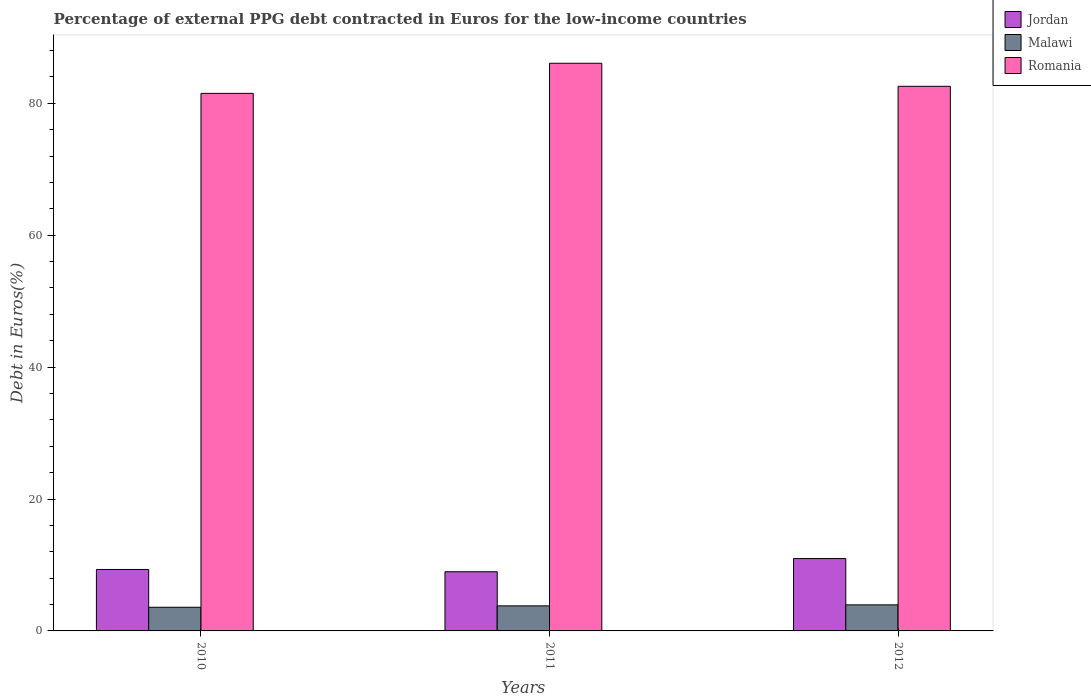Are the number of bars on each tick of the X-axis equal?
Your answer should be very brief. Yes. What is the label of the 2nd group of bars from the left?
Offer a very short reply. 2011. In how many cases, is the number of bars for a given year not equal to the number of legend labels?
Your answer should be compact. 0. What is the percentage of external PPG debt contracted in Euros in Jordan in 2012?
Keep it short and to the point. 10.97. Across all years, what is the maximum percentage of external PPG debt contracted in Euros in Jordan?
Provide a succinct answer. 10.97. Across all years, what is the minimum percentage of external PPG debt contracted in Euros in Romania?
Give a very brief answer. 81.51. In which year was the percentage of external PPG debt contracted in Euros in Malawi maximum?
Keep it short and to the point. 2012. What is the total percentage of external PPG debt contracted in Euros in Malawi in the graph?
Provide a succinct answer. 11.34. What is the difference between the percentage of external PPG debt contracted in Euros in Jordan in 2010 and that in 2011?
Provide a succinct answer. 0.34. What is the difference between the percentage of external PPG debt contracted in Euros in Jordan in 2011 and the percentage of external PPG debt contracted in Euros in Romania in 2010?
Offer a terse response. -72.53. What is the average percentage of external PPG debt contracted in Euros in Malawi per year?
Your answer should be very brief. 3.78. In the year 2012, what is the difference between the percentage of external PPG debt contracted in Euros in Jordan and percentage of external PPG debt contracted in Euros in Malawi?
Provide a succinct answer. 7.02. What is the ratio of the percentage of external PPG debt contracted in Euros in Malawi in 2011 to that in 2012?
Your answer should be very brief. 0.96. What is the difference between the highest and the second highest percentage of external PPG debt contracted in Euros in Romania?
Your answer should be compact. 3.49. What is the difference between the highest and the lowest percentage of external PPG debt contracted in Euros in Romania?
Your answer should be compact. 4.57. What does the 3rd bar from the left in 2012 represents?
Provide a succinct answer. Romania. What does the 3rd bar from the right in 2010 represents?
Offer a terse response. Jordan. Are all the bars in the graph horizontal?
Keep it short and to the point. No. How many years are there in the graph?
Your answer should be very brief. 3. Does the graph contain any zero values?
Ensure brevity in your answer.  No. Does the graph contain grids?
Your response must be concise. No. What is the title of the graph?
Your answer should be very brief. Percentage of external PPG debt contracted in Euros for the low-income countries. What is the label or title of the X-axis?
Make the answer very short. Years. What is the label or title of the Y-axis?
Your response must be concise. Debt in Euros(%). What is the Debt in Euros(%) of Jordan in 2010?
Your answer should be very brief. 9.32. What is the Debt in Euros(%) in Malawi in 2010?
Your answer should be compact. 3.59. What is the Debt in Euros(%) of Romania in 2010?
Offer a very short reply. 81.51. What is the Debt in Euros(%) in Jordan in 2011?
Offer a very short reply. 8.97. What is the Debt in Euros(%) of Malawi in 2011?
Give a very brief answer. 3.8. What is the Debt in Euros(%) in Romania in 2011?
Your answer should be very brief. 86.07. What is the Debt in Euros(%) in Jordan in 2012?
Your answer should be very brief. 10.97. What is the Debt in Euros(%) in Malawi in 2012?
Provide a short and direct response. 3.95. What is the Debt in Euros(%) in Romania in 2012?
Your answer should be compact. 82.58. Across all years, what is the maximum Debt in Euros(%) of Jordan?
Your response must be concise. 10.97. Across all years, what is the maximum Debt in Euros(%) in Malawi?
Provide a succinct answer. 3.95. Across all years, what is the maximum Debt in Euros(%) of Romania?
Keep it short and to the point. 86.07. Across all years, what is the minimum Debt in Euros(%) of Jordan?
Ensure brevity in your answer.  8.97. Across all years, what is the minimum Debt in Euros(%) of Malawi?
Keep it short and to the point. 3.59. Across all years, what is the minimum Debt in Euros(%) of Romania?
Offer a very short reply. 81.51. What is the total Debt in Euros(%) of Jordan in the graph?
Your response must be concise. 29.26. What is the total Debt in Euros(%) in Malawi in the graph?
Your answer should be compact. 11.34. What is the total Debt in Euros(%) in Romania in the graph?
Your answer should be compact. 250.16. What is the difference between the Debt in Euros(%) of Jordan in 2010 and that in 2011?
Make the answer very short. 0.34. What is the difference between the Debt in Euros(%) in Malawi in 2010 and that in 2011?
Keep it short and to the point. -0.21. What is the difference between the Debt in Euros(%) of Romania in 2010 and that in 2011?
Provide a succinct answer. -4.57. What is the difference between the Debt in Euros(%) in Jordan in 2010 and that in 2012?
Give a very brief answer. -1.66. What is the difference between the Debt in Euros(%) of Malawi in 2010 and that in 2012?
Your answer should be compact. -0.36. What is the difference between the Debt in Euros(%) in Romania in 2010 and that in 2012?
Ensure brevity in your answer.  -1.07. What is the difference between the Debt in Euros(%) of Jordan in 2011 and that in 2012?
Provide a short and direct response. -2. What is the difference between the Debt in Euros(%) in Malawi in 2011 and that in 2012?
Keep it short and to the point. -0.15. What is the difference between the Debt in Euros(%) of Romania in 2011 and that in 2012?
Provide a short and direct response. 3.49. What is the difference between the Debt in Euros(%) of Jordan in 2010 and the Debt in Euros(%) of Malawi in 2011?
Offer a terse response. 5.52. What is the difference between the Debt in Euros(%) of Jordan in 2010 and the Debt in Euros(%) of Romania in 2011?
Your response must be concise. -76.76. What is the difference between the Debt in Euros(%) of Malawi in 2010 and the Debt in Euros(%) of Romania in 2011?
Keep it short and to the point. -82.48. What is the difference between the Debt in Euros(%) in Jordan in 2010 and the Debt in Euros(%) in Malawi in 2012?
Your answer should be compact. 5.37. What is the difference between the Debt in Euros(%) in Jordan in 2010 and the Debt in Euros(%) in Romania in 2012?
Ensure brevity in your answer.  -73.26. What is the difference between the Debt in Euros(%) in Malawi in 2010 and the Debt in Euros(%) in Romania in 2012?
Offer a very short reply. -78.99. What is the difference between the Debt in Euros(%) of Jordan in 2011 and the Debt in Euros(%) of Malawi in 2012?
Your answer should be compact. 5.02. What is the difference between the Debt in Euros(%) of Jordan in 2011 and the Debt in Euros(%) of Romania in 2012?
Provide a succinct answer. -73.61. What is the difference between the Debt in Euros(%) in Malawi in 2011 and the Debt in Euros(%) in Romania in 2012?
Provide a succinct answer. -78.78. What is the average Debt in Euros(%) of Jordan per year?
Provide a succinct answer. 9.75. What is the average Debt in Euros(%) in Malawi per year?
Your answer should be compact. 3.78. What is the average Debt in Euros(%) in Romania per year?
Your answer should be compact. 83.39. In the year 2010, what is the difference between the Debt in Euros(%) of Jordan and Debt in Euros(%) of Malawi?
Offer a terse response. 5.73. In the year 2010, what is the difference between the Debt in Euros(%) in Jordan and Debt in Euros(%) in Romania?
Keep it short and to the point. -72.19. In the year 2010, what is the difference between the Debt in Euros(%) of Malawi and Debt in Euros(%) of Romania?
Offer a very short reply. -77.92. In the year 2011, what is the difference between the Debt in Euros(%) in Jordan and Debt in Euros(%) in Malawi?
Your response must be concise. 5.17. In the year 2011, what is the difference between the Debt in Euros(%) in Jordan and Debt in Euros(%) in Romania?
Your answer should be very brief. -77.1. In the year 2011, what is the difference between the Debt in Euros(%) in Malawi and Debt in Euros(%) in Romania?
Make the answer very short. -82.28. In the year 2012, what is the difference between the Debt in Euros(%) of Jordan and Debt in Euros(%) of Malawi?
Provide a succinct answer. 7.02. In the year 2012, what is the difference between the Debt in Euros(%) of Jordan and Debt in Euros(%) of Romania?
Make the answer very short. -71.61. In the year 2012, what is the difference between the Debt in Euros(%) of Malawi and Debt in Euros(%) of Romania?
Give a very brief answer. -78.63. What is the ratio of the Debt in Euros(%) in Jordan in 2010 to that in 2011?
Offer a terse response. 1.04. What is the ratio of the Debt in Euros(%) of Malawi in 2010 to that in 2011?
Offer a very short reply. 0.94. What is the ratio of the Debt in Euros(%) of Romania in 2010 to that in 2011?
Make the answer very short. 0.95. What is the ratio of the Debt in Euros(%) in Jordan in 2010 to that in 2012?
Give a very brief answer. 0.85. What is the ratio of the Debt in Euros(%) of Malawi in 2010 to that in 2012?
Provide a succinct answer. 0.91. What is the ratio of the Debt in Euros(%) of Jordan in 2011 to that in 2012?
Your answer should be very brief. 0.82. What is the ratio of the Debt in Euros(%) in Malawi in 2011 to that in 2012?
Make the answer very short. 0.96. What is the ratio of the Debt in Euros(%) of Romania in 2011 to that in 2012?
Your answer should be compact. 1.04. What is the difference between the highest and the second highest Debt in Euros(%) of Jordan?
Ensure brevity in your answer.  1.66. What is the difference between the highest and the second highest Debt in Euros(%) in Malawi?
Offer a terse response. 0.15. What is the difference between the highest and the second highest Debt in Euros(%) in Romania?
Your answer should be very brief. 3.49. What is the difference between the highest and the lowest Debt in Euros(%) in Jordan?
Keep it short and to the point. 2. What is the difference between the highest and the lowest Debt in Euros(%) in Malawi?
Provide a succinct answer. 0.36. What is the difference between the highest and the lowest Debt in Euros(%) of Romania?
Offer a very short reply. 4.57. 